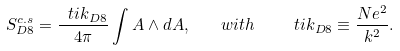<formula> <loc_0><loc_0><loc_500><loc_500>S ^ { c . s } _ { D 8 } = \frac { \ t i { k } _ { D 8 } } { 4 \pi } \int A \wedge d A , \quad w i t h \quad \ t i { k } _ { D 8 } \equiv \frac { N e ^ { 2 } } { k ^ { 2 } } .</formula> 